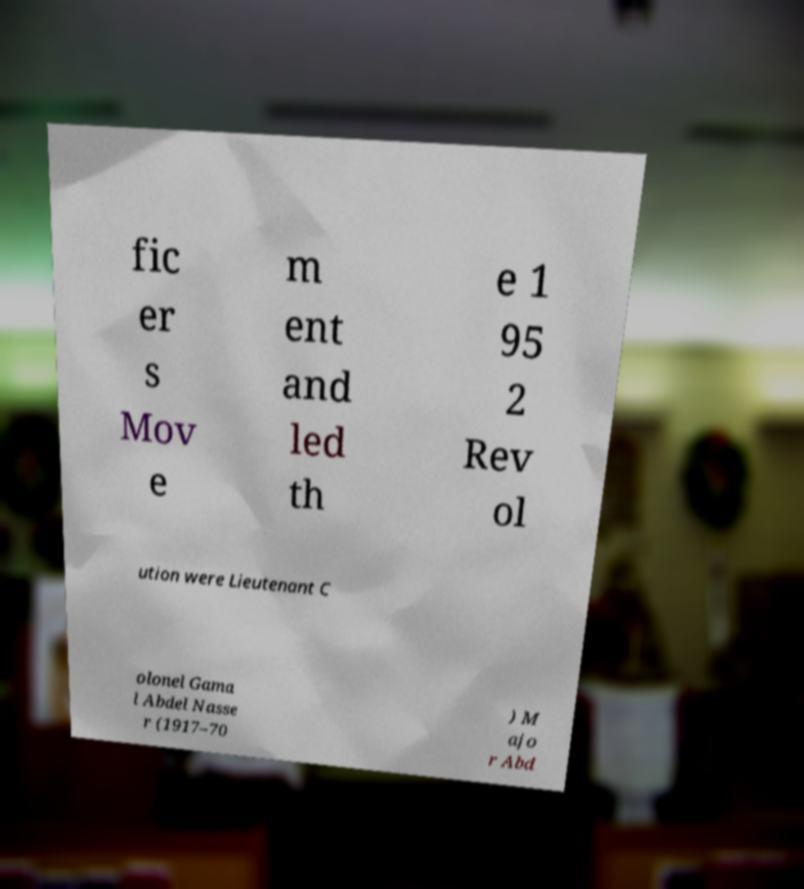For documentation purposes, I need the text within this image transcribed. Could you provide that? fic er s Mov e m ent and led th e 1 95 2 Rev ol ution were Lieutenant C olonel Gama l Abdel Nasse r (1917–70 ) M ajo r Abd 